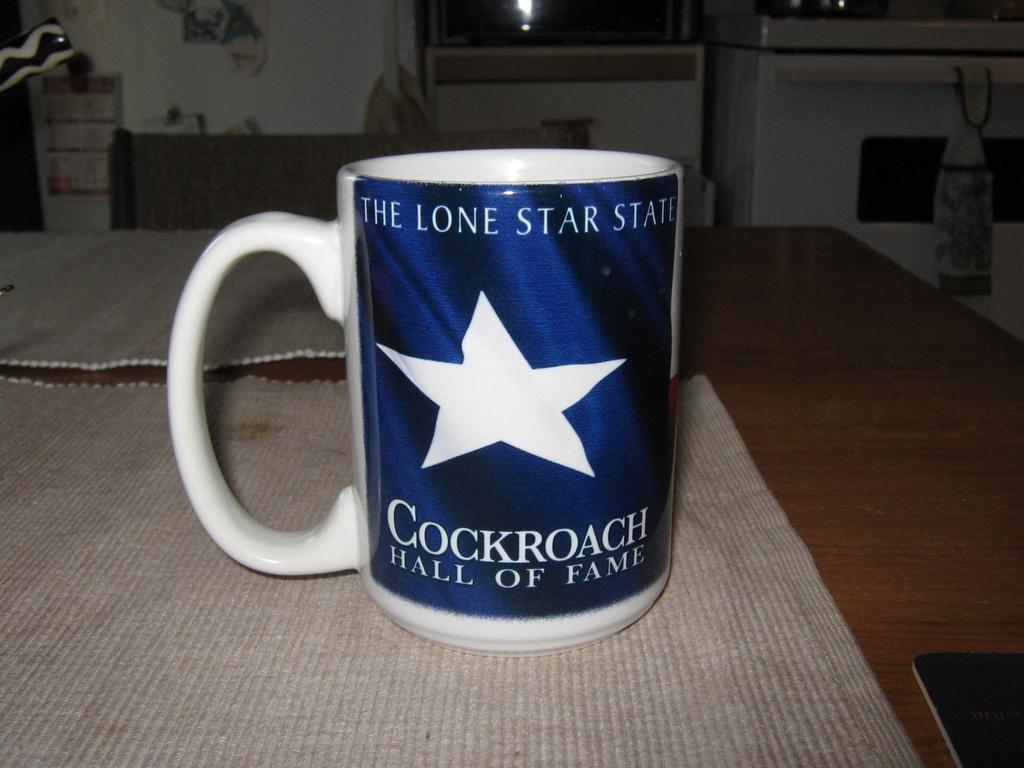<image>
Create a compact narrative representing the image presented. A coffee mug that says the Lone Star State. 